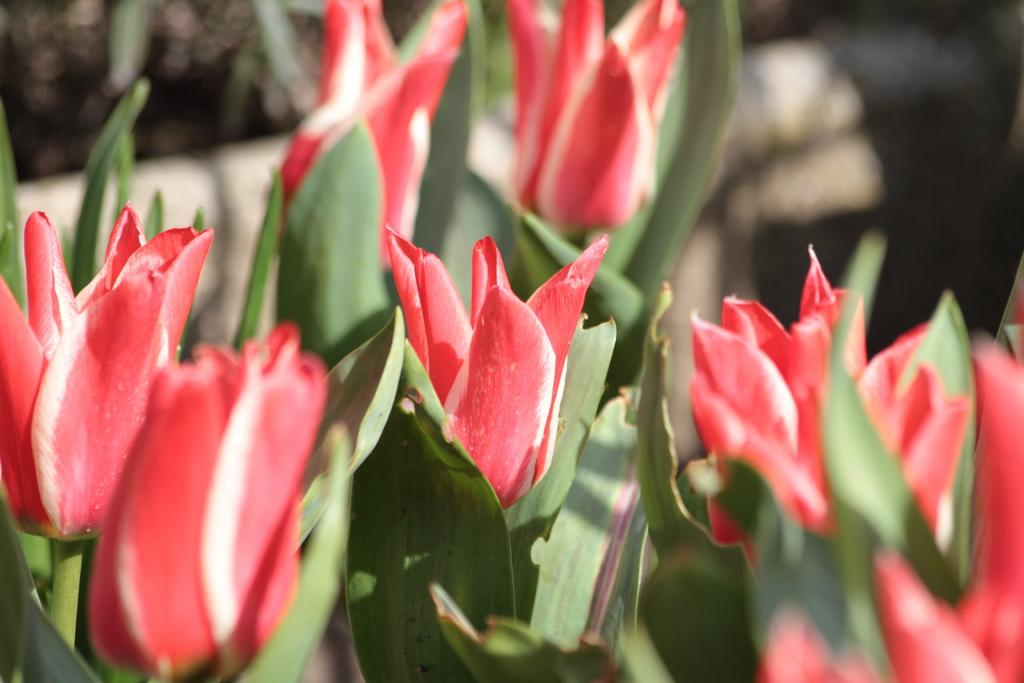What type of living organisms are present in the image? There are plants in the image. What color are the flowers on the plants? The flowers on the plants are red. Can you describe the background of the image? The background of the image is blurred. What type of work does the army do in the image? There is no army or work-related activity present in the image; it features plants with red flowers and a blurred background. 